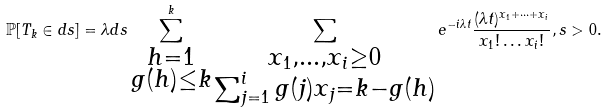<formula> <loc_0><loc_0><loc_500><loc_500>\mathbb { P } [ T _ { k } \in d s ] = \lambda d s \sum _ { \substack { { h = 1 } \\ g ( h ) \leq k } } ^ { k } \sum _ { \substack { x _ { 1 } , \dots , x _ { i } \geq 0 \\ \sum _ { j = 1 } ^ { i } g ( j ) x _ { j } = k - g ( h ) } } e ^ { - i \lambda t } \frac { ( \lambda t ) ^ { x _ { 1 } + \dots + x _ { i } } } { x _ { 1 } ! \dots x _ { i } ! } , s > 0 .</formula> 